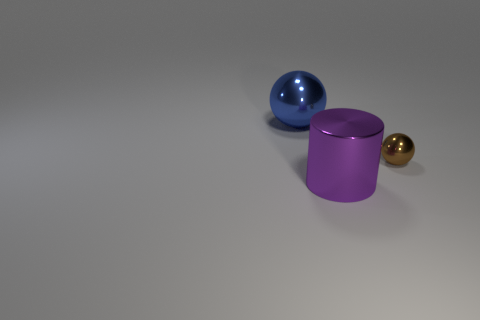Add 3 small cyan spheres. How many objects exist? 6 Subtract all blue spheres. How many spheres are left? 1 Subtract all spheres. How many objects are left? 1 Subtract all purple metallic cylinders. Subtract all blue metal objects. How many objects are left? 1 Add 2 large shiny spheres. How many large shiny spheres are left? 3 Add 3 large shiny balls. How many large shiny balls exist? 4 Subtract 0 brown cylinders. How many objects are left? 3 Subtract 2 balls. How many balls are left? 0 Subtract all blue balls. Subtract all brown cylinders. How many balls are left? 1 Subtract all blue spheres. How many gray cylinders are left? 0 